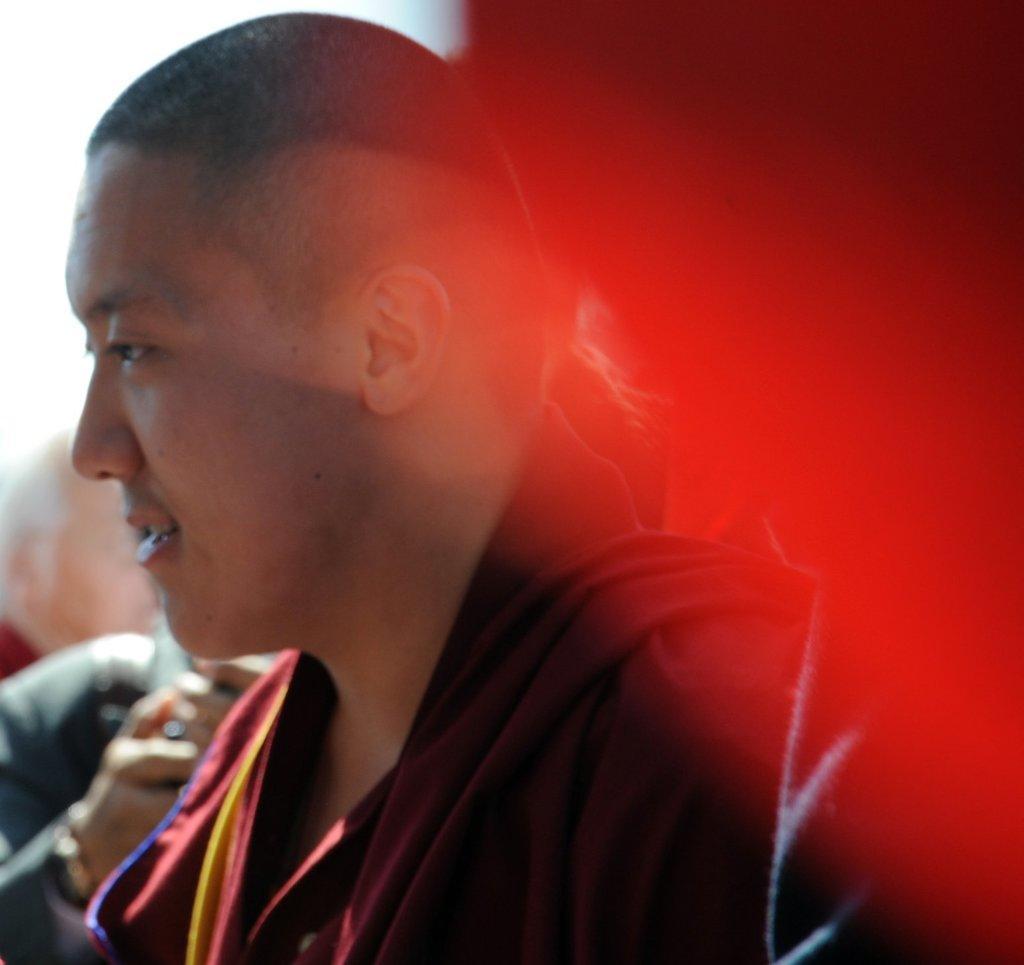Can you describe this image briefly? In this image, we can see a person. Background there are few people. Right side of the image, we can see red color. 